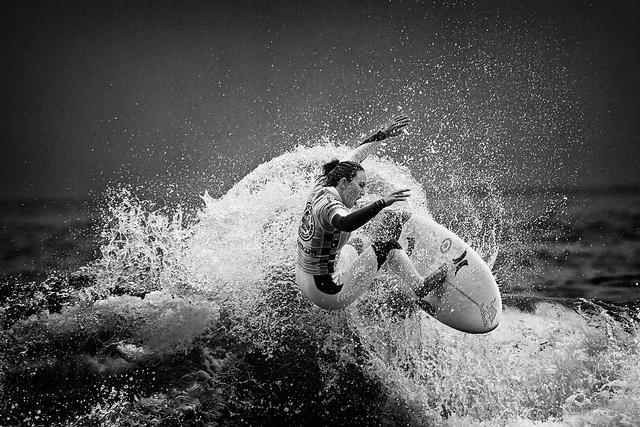What sport is being practiced in the scene?
Write a very short answer. Surfing. Was this picture taken before color film was invented?
Keep it brief. No. Is this woman rolling skating?
Concise answer only. No. 